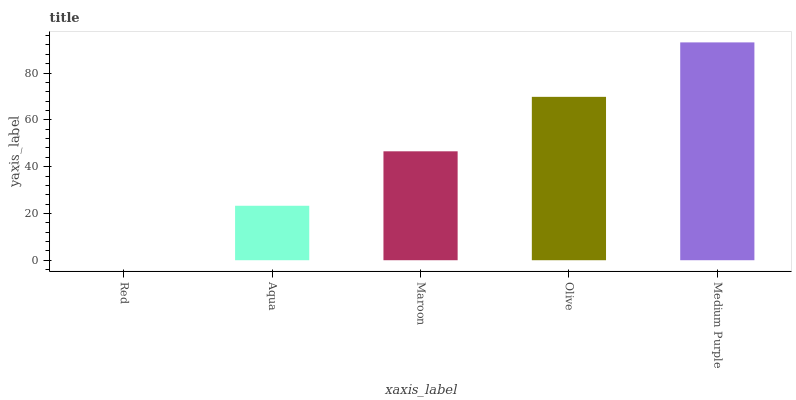Is Red the minimum?
Answer yes or no. Yes. Is Medium Purple the maximum?
Answer yes or no. Yes. Is Aqua the minimum?
Answer yes or no. No. Is Aqua the maximum?
Answer yes or no. No. Is Aqua greater than Red?
Answer yes or no. Yes. Is Red less than Aqua?
Answer yes or no. Yes. Is Red greater than Aqua?
Answer yes or no. No. Is Aqua less than Red?
Answer yes or no. No. Is Maroon the high median?
Answer yes or no. Yes. Is Maroon the low median?
Answer yes or no. Yes. Is Medium Purple the high median?
Answer yes or no. No. Is Olive the low median?
Answer yes or no. No. 